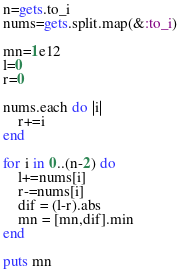<code> <loc_0><loc_0><loc_500><loc_500><_Ruby_>n=gets.to_i
nums=gets.split.map(&:to_i)

mn=1e12
l=0
r=0

nums.each do |i|
    r+=i
end

for i in 0..(n-2) do
    l+=nums[i]
    r-=nums[i]
    dif = (l-r).abs
    mn = [mn,dif].min
end

puts mn</code> 